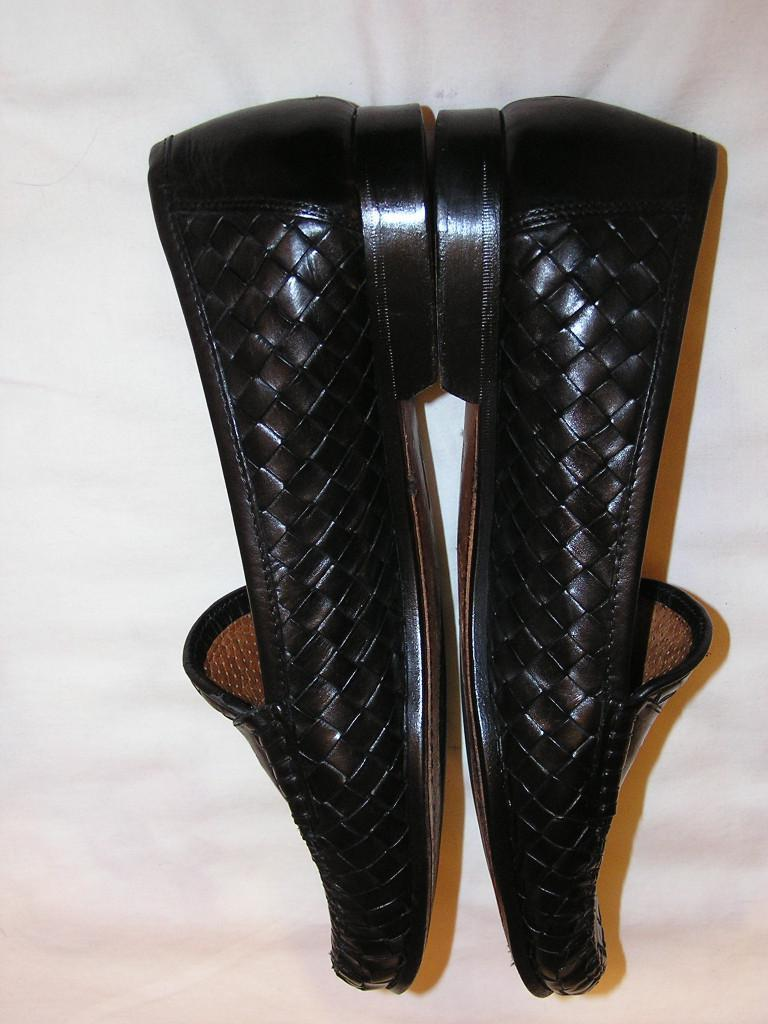What is the main subject of the image? The main subject of the image is a pair of shoes. Where are the shoes located in the image? The shoes are in the center of the image. What type of skin can be seen on the shoes in the image? There is no skin visible on the shoes in the image; they are made of fabric or other materials. 